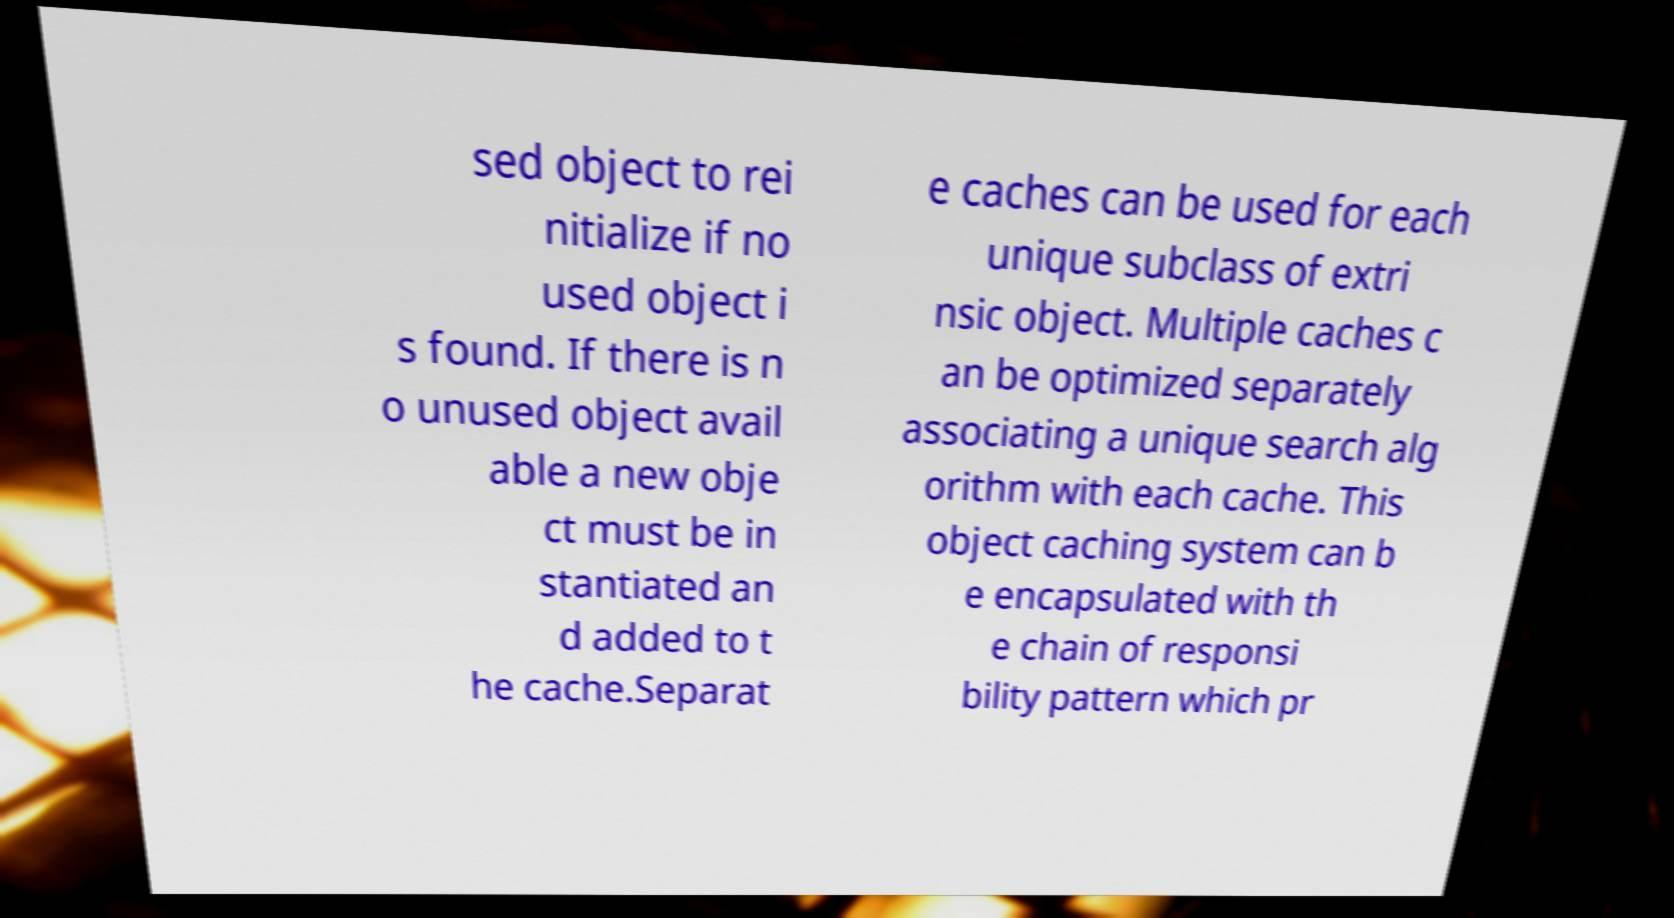I need the written content from this picture converted into text. Can you do that? sed object to rei nitialize if no used object i s found. If there is n o unused object avail able a new obje ct must be in stantiated an d added to t he cache.Separat e caches can be used for each unique subclass of extri nsic object. Multiple caches c an be optimized separately associating a unique search alg orithm with each cache. This object caching system can b e encapsulated with th e chain of responsi bility pattern which pr 